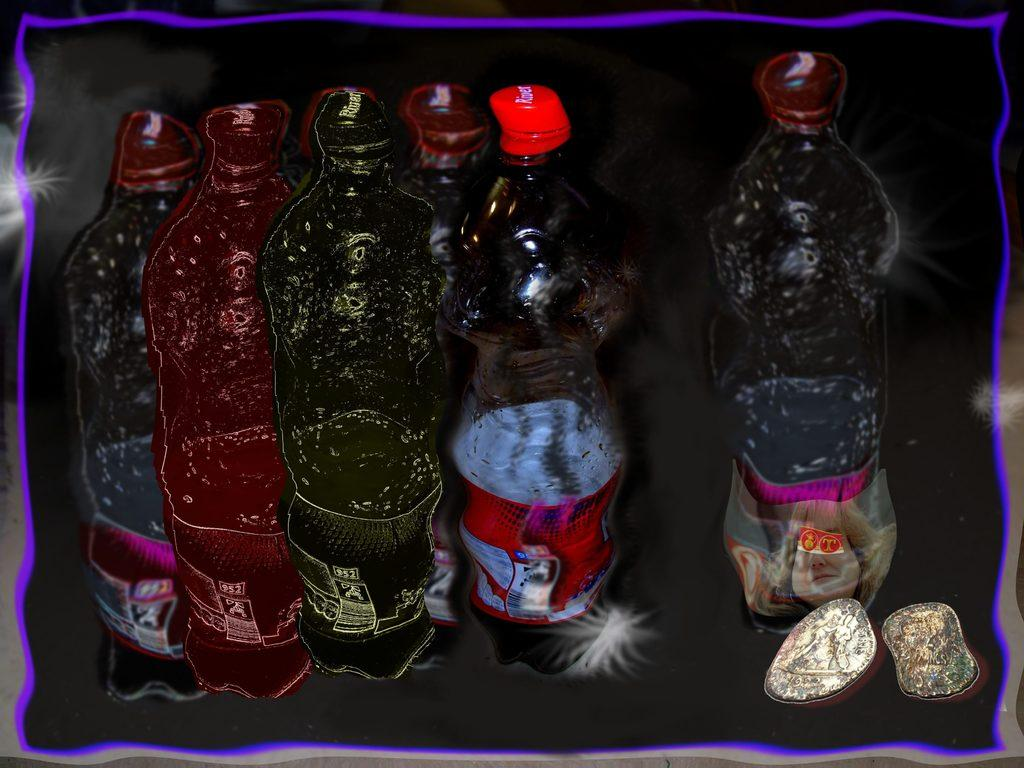What objects are present in the image? There are bottles in the image. What is on the bottles? There are stickers on the bottles. How many things can be counted in the image? There are 2 things in the image. Where is the hen located in the image? There is no hen present in the image. What type of waste can be seen in the image? There is no waste present in the image. Is there a river visible in the image? There is no river present in the image. 